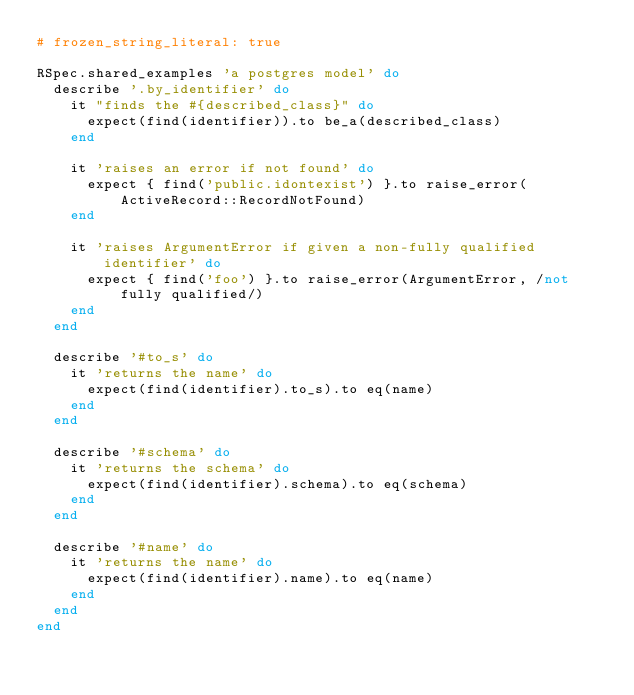<code> <loc_0><loc_0><loc_500><loc_500><_Ruby_># frozen_string_literal: true

RSpec.shared_examples 'a postgres model' do
  describe '.by_identifier' do
    it "finds the #{described_class}" do
      expect(find(identifier)).to be_a(described_class)
    end

    it 'raises an error if not found' do
      expect { find('public.idontexist') }.to raise_error(ActiveRecord::RecordNotFound)
    end

    it 'raises ArgumentError if given a non-fully qualified identifier' do
      expect { find('foo') }.to raise_error(ArgumentError, /not fully qualified/)
    end
  end

  describe '#to_s' do
    it 'returns the name' do
      expect(find(identifier).to_s).to eq(name)
    end
  end

  describe '#schema' do
    it 'returns the schema' do
      expect(find(identifier).schema).to eq(schema)
    end
  end

  describe '#name' do
    it 'returns the name' do
      expect(find(identifier).name).to eq(name)
    end
  end
end
</code> 